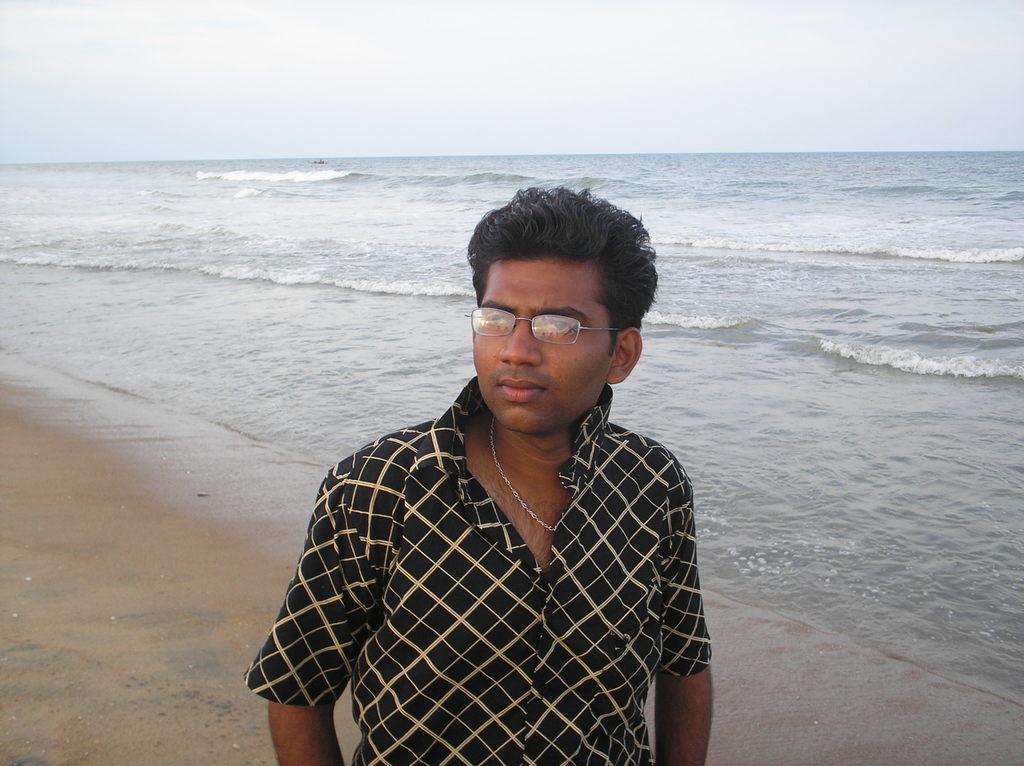Can you describe this image briefly? In this image I can see the person and the person is wearing black and cream color shirt. In the background I can see the sea and the sky is in white and blue color. 